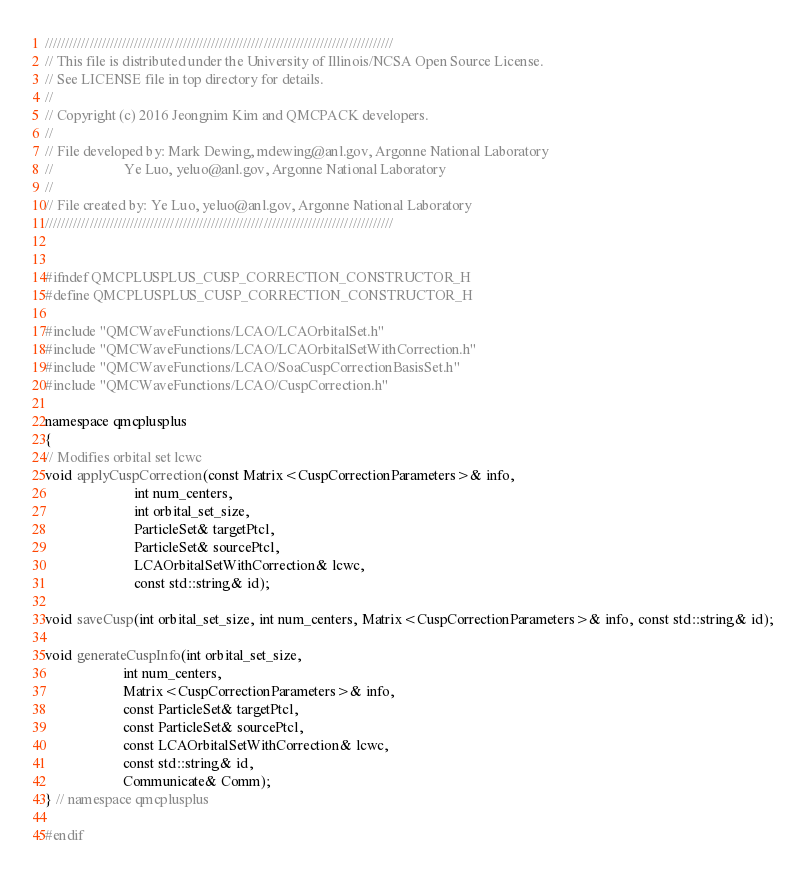<code> <loc_0><loc_0><loc_500><loc_500><_C_>//////////////////////////////////////////////////////////////////////////////////////
// This file is distributed under the University of Illinois/NCSA Open Source License.
// See LICENSE file in top directory for details.
//
// Copyright (c) 2016 Jeongnim Kim and QMCPACK developers.
//
// File developed by: Mark Dewing, mdewing@anl.gov, Argonne National Laboratory
//                    Ye Luo, yeluo@anl.gov, Argonne National Laboratory
//
// File created by: Ye Luo, yeluo@anl.gov, Argonne National Laboratory
//////////////////////////////////////////////////////////////////////////////////////


#ifndef QMCPLUSPLUS_CUSP_CORRECTION_CONSTRUCTOR_H
#define QMCPLUSPLUS_CUSP_CORRECTION_CONSTRUCTOR_H

#include "QMCWaveFunctions/LCAO/LCAOrbitalSet.h"
#include "QMCWaveFunctions/LCAO/LCAOrbitalSetWithCorrection.h"
#include "QMCWaveFunctions/LCAO/SoaCuspCorrectionBasisSet.h"
#include "QMCWaveFunctions/LCAO/CuspCorrection.h"

namespace qmcplusplus
{
// Modifies orbital set lcwc
void applyCuspCorrection(const Matrix<CuspCorrectionParameters>& info,
                         int num_centers,
                         int orbital_set_size,
                         ParticleSet& targetPtcl,
                         ParticleSet& sourcePtcl,
                         LCAOrbitalSetWithCorrection& lcwc,
                         const std::string& id);

void saveCusp(int orbital_set_size, int num_centers, Matrix<CuspCorrectionParameters>& info, const std::string& id);

void generateCuspInfo(int orbital_set_size,
                      int num_centers,
                      Matrix<CuspCorrectionParameters>& info,
                      const ParticleSet& targetPtcl,
                      const ParticleSet& sourcePtcl,
                      const LCAOrbitalSetWithCorrection& lcwc,
                      const std::string& id,
                      Communicate& Comm);
} // namespace qmcplusplus

#endif
</code> 